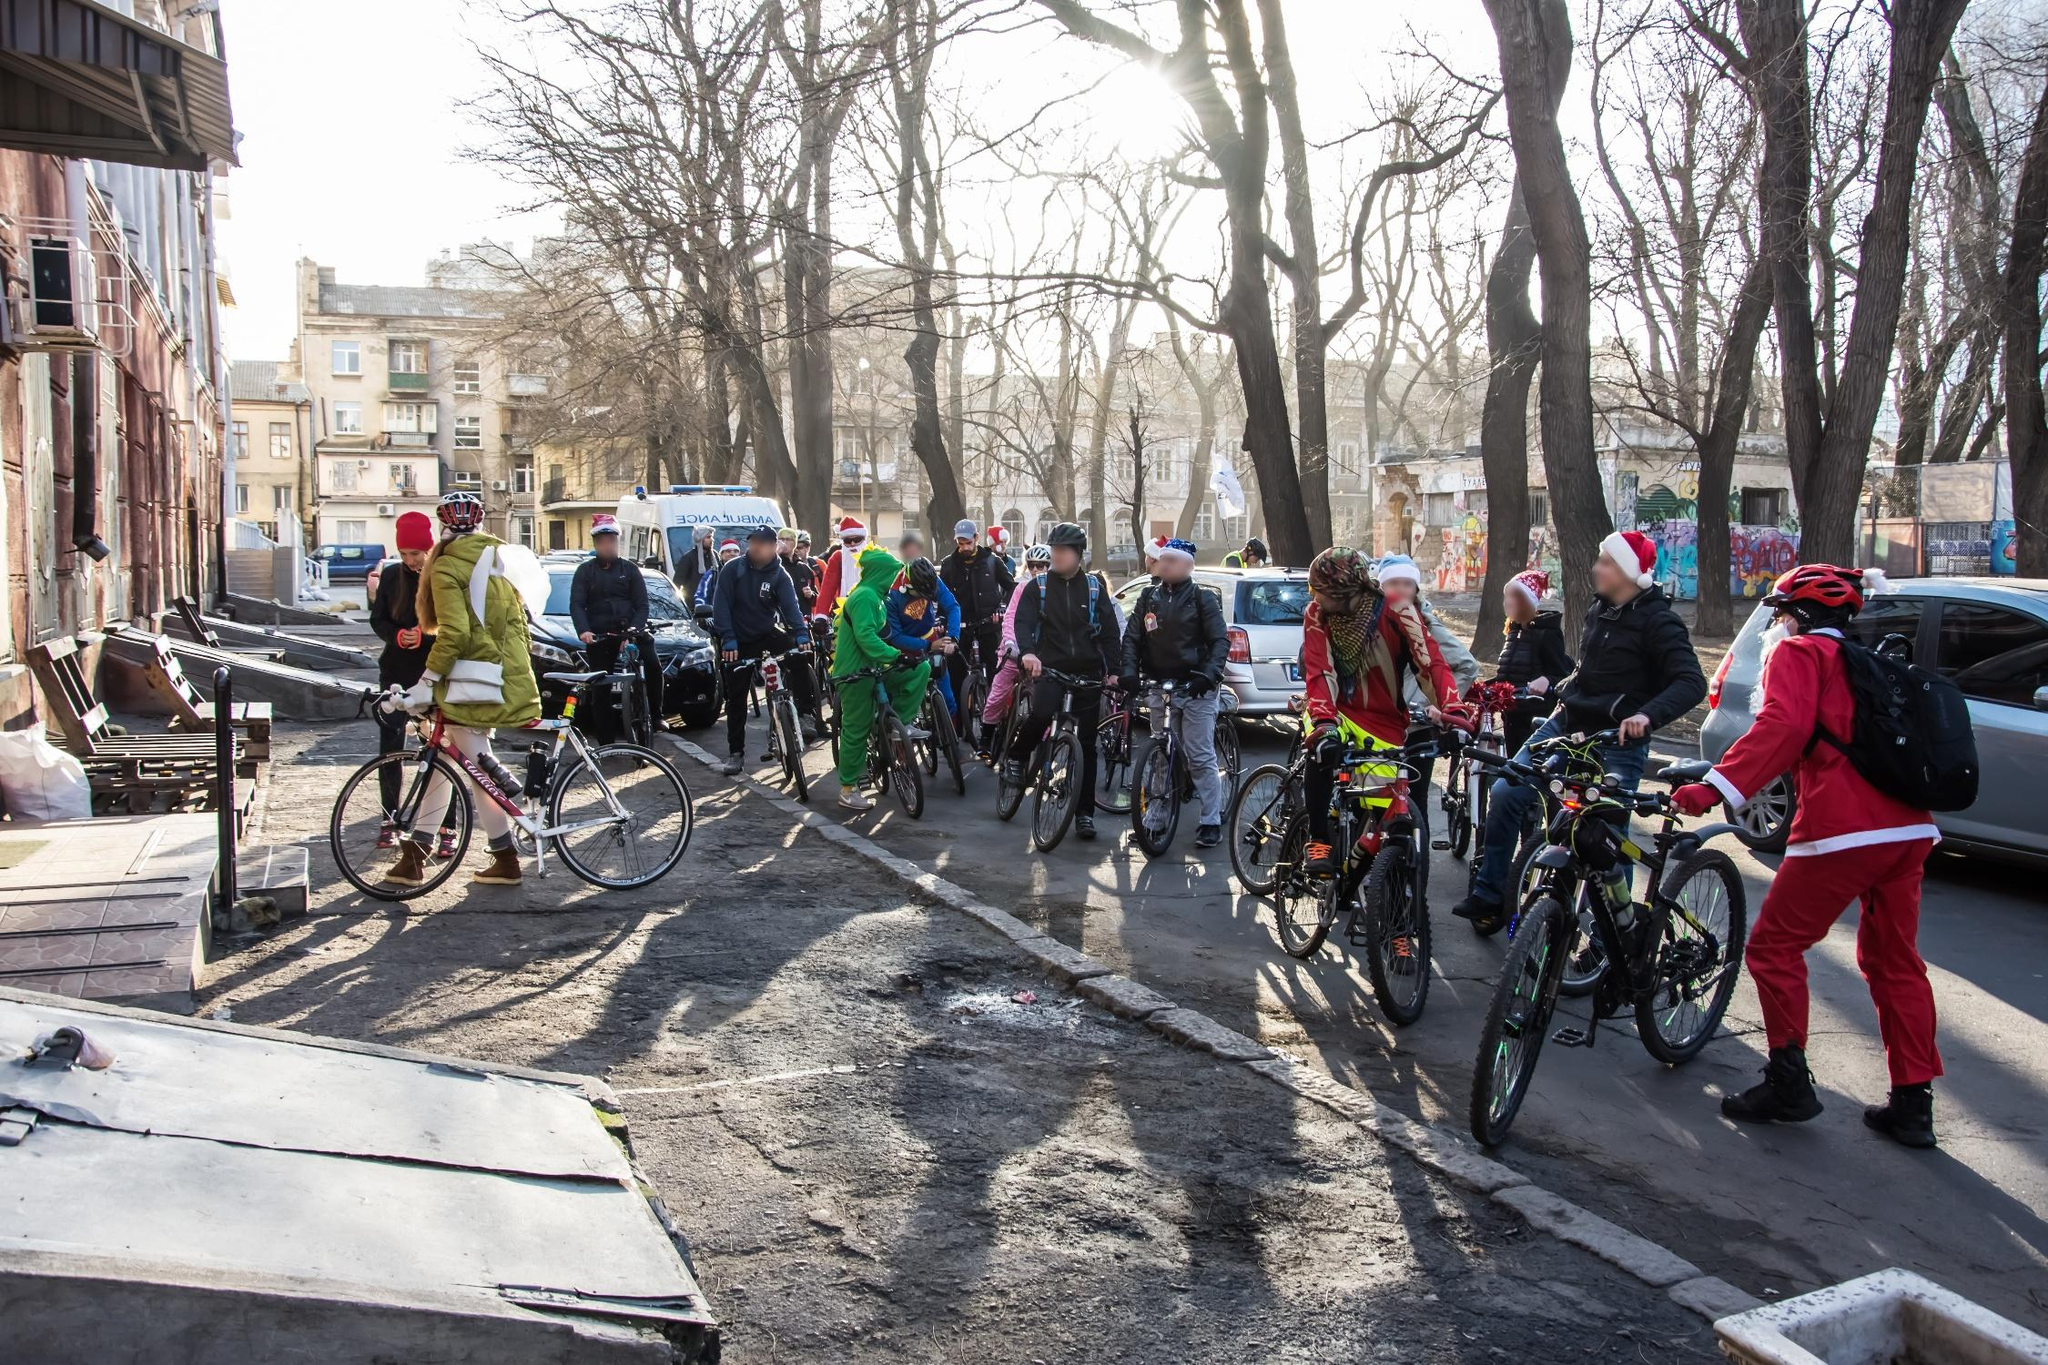How might this scene look different if it was set in a different season? If this scene were set in spring, the bare trees would be covered in fresh, green foliage, and the participants might be dressed in bright, floral-themed costumes celebrating the arrival of the season. The city's streets would be adorned with blooming flowers, and the atmosphere would be one of renewal and freshness, celebrating a new beginning. How could the event adapt to a summer setting? In a summer setting, the event could take on a 'Summer Spectacular' theme, with cyclists donning Hawaiian shirts, sunglasses, and beach-themed outfits. The route could feature hydration stations with cold drinks and misting fans to keep participants cool. The festive spirit would be in full swing with ice-cream trucks, music playing from speakers carried by participants, and a grand finale with a beach party at a local park featuring water games, barbecues, and fireworks. The image would radiate warmth, sunshine, and the carefree joy of the summer season. 